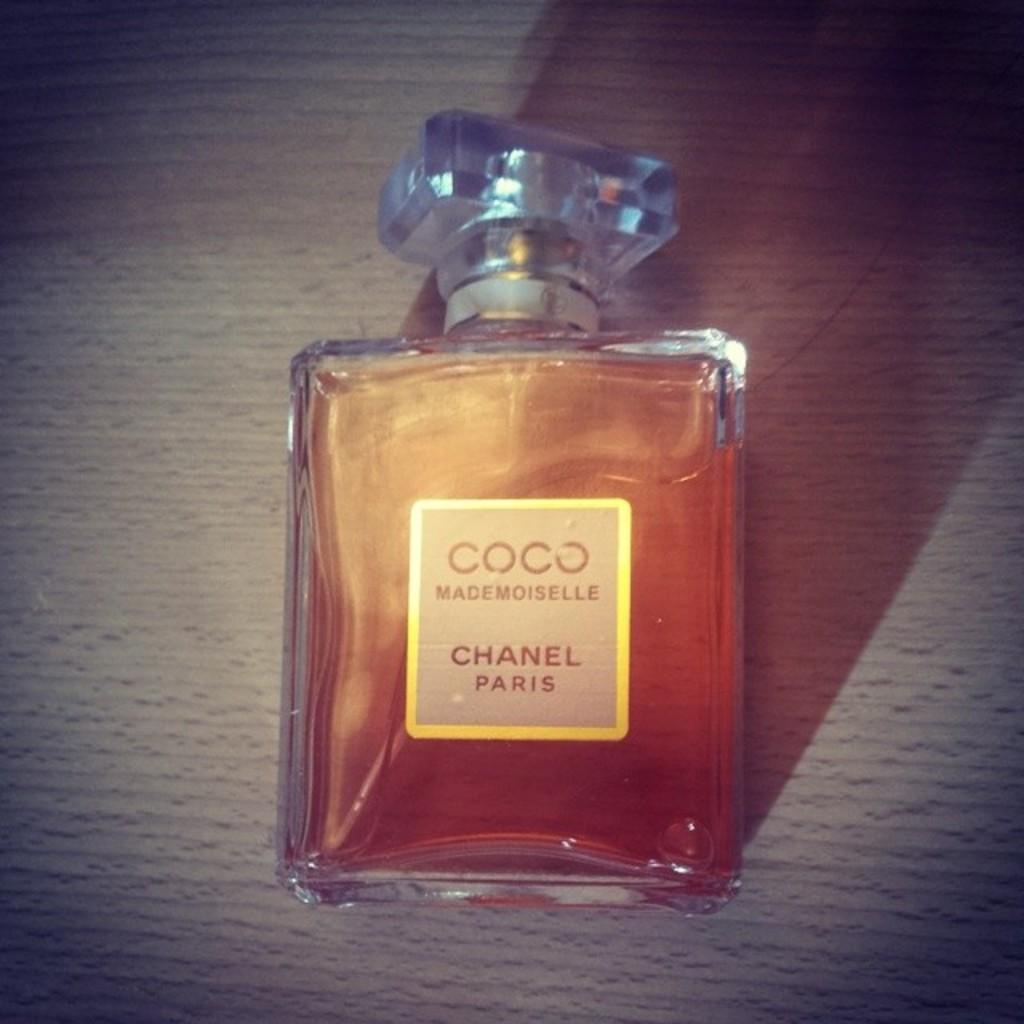<image>
Describe the image concisely. A bottle of Coco Mademoiselle perfume by Chanel Paris. 